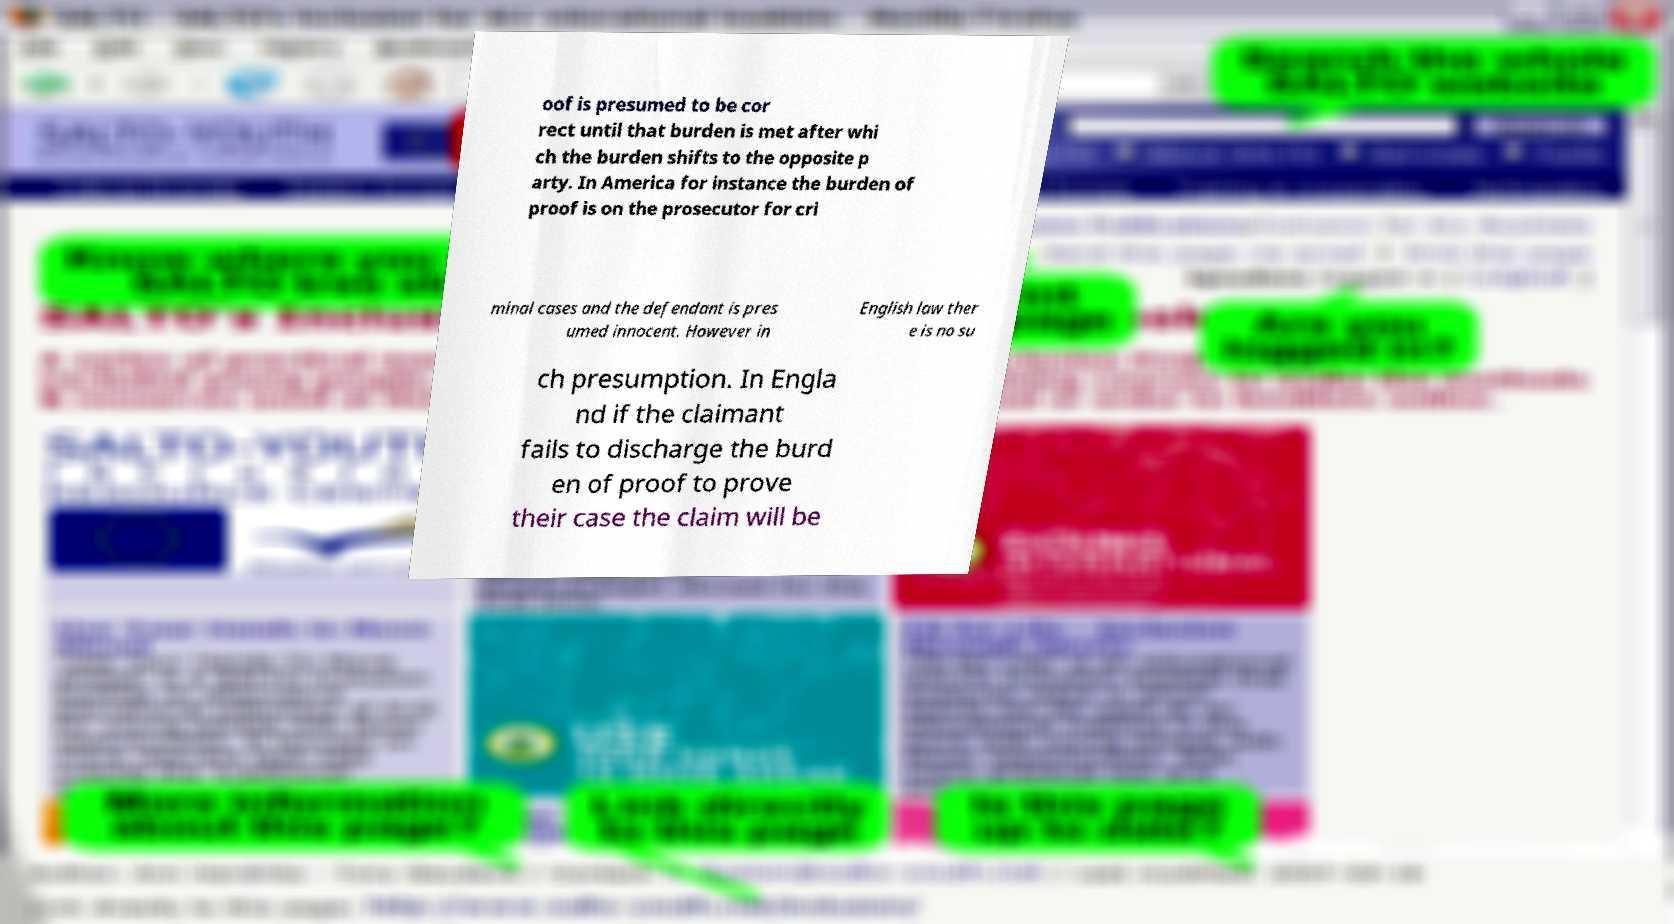Could you extract and type out the text from this image? oof is presumed to be cor rect until that burden is met after whi ch the burden shifts to the opposite p arty. In America for instance the burden of proof is on the prosecutor for cri minal cases and the defendant is pres umed innocent. However in English law ther e is no su ch presumption. In Engla nd if the claimant fails to discharge the burd en of proof to prove their case the claim will be 